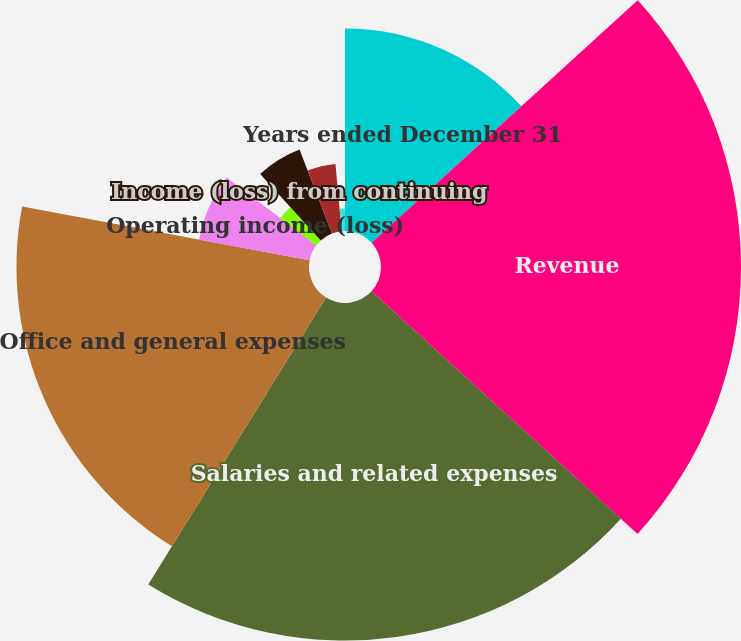Convert chart. <chart><loc_0><loc_0><loc_500><loc_500><pie_chart><fcel>Years ended December 31<fcel>Revenue<fcel>Salaries and related expenses<fcel>Office and general expenses<fcel>Operating income (loss)<fcel>Provision for income taxes<fcel>Income (loss) from continuing<fcel>Net income (loss) available to<fcel>Continuing operations<fcel>Total<nl><fcel>13.24%<fcel>23.53%<fcel>22.06%<fcel>19.12%<fcel>7.35%<fcel>2.94%<fcel>5.88%<fcel>4.41%<fcel>0.0%<fcel>1.47%<nl></chart> 